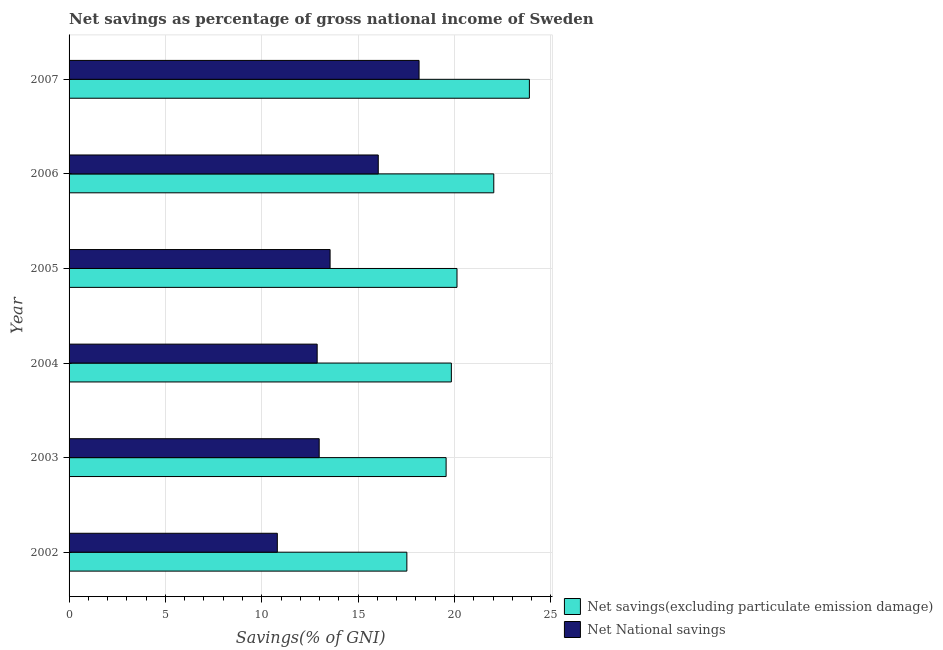How many bars are there on the 6th tick from the top?
Offer a very short reply. 2. What is the label of the 1st group of bars from the top?
Your response must be concise. 2007. What is the net savings(excluding particulate emission damage) in 2007?
Offer a very short reply. 23.89. Across all years, what is the maximum net savings(excluding particulate emission damage)?
Your response must be concise. 23.89. Across all years, what is the minimum net national savings?
Give a very brief answer. 10.81. In which year was the net savings(excluding particulate emission damage) maximum?
Keep it short and to the point. 2007. In which year was the net national savings minimum?
Give a very brief answer. 2002. What is the total net national savings in the graph?
Keep it short and to the point. 84.41. What is the difference between the net national savings in 2003 and that in 2006?
Make the answer very short. -3.07. What is the difference between the net savings(excluding particulate emission damage) in 2003 and the net national savings in 2004?
Your answer should be compact. 6.69. What is the average net national savings per year?
Ensure brevity in your answer.  14.07. In the year 2007, what is the difference between the net savings(excluding particulate emission damage) and net national savings?
Your answer should be compact. 5.73. What is the ratio of the net national savings in 2004 to that in 2006?
Your answer should be compact. 0.8. Is the difference between the net national savings in 2002 and 2006 greater than the difference between the net savings(excluding particulate emission damage) in 2002 and 2006?
Your answer should be very brief. No. What is the difference between the highest and the second highest net national savings?
Your answer should be very brief. 2.12. What is the difference between the highest and the lowest net national savings?
Your response must be concise. 7.35. In how many years, is the net national savings greater than the average net national savings taken over all years?
Make the answer very short. 2. What does the 1st bar from the top in 2002 represents?
Your answer should be very brief. Net National savings. What does the 2nd bar from the bottom in 2002 represents?
Your answer should be very brief. Net National savings. How many bars are there?
Your answer should be very brief. 12. How many years are there in the graph?
Your answer should be very brief. 6. What is the difference between two consecutive major ticks on the X-axis?
Provide a short and direct response. 5. Does the graph contain any zero values?
Make the answer very short. No. Does the graph contain grids?
Provide a succinct answer. Yes. How are the legend labels stacked?
Provide a succinct answer. Vertical. What is the title of the graph?
Your answer should be very brief. Net savings as percentage of gross national income of Sweden. What is the label or title of the X-axis?
Offer a very short reply. Savings(% of GNI). What is the Savings(% of GNI) of Net savings(excluding particulate emission damage) in 2002?
Keep it short and to the point. 17.53. What is the Savings(% of GNI) in Net National savings in 2002?
Make the answer very short. 10.81. What is the Savings(% of GNI) of Net savings(excluding particulate emission damage) in 2003?
Offer a very short reply. 19.57. What is the Savings(% of GNI) in Net National savings in 2003?
Offer a terse response. 12.98. What is the Savings(% of GNI) in Net savings(excluding particulate emission damage) in 2004?
Ensure brevity in your answer.  19.84. What is the Savings(% of GNI) of Net National savings in 2004?
Your answer should be very brief. 12.87. What is the Savings(% of GNI) in Net savings(excluding particulate emission damage) in 2005?
Ensure brevity in your answer.  20.13. What is the Savings(% of GNI) of Net National savings in 2005?
Make the answer very short. 13.54. What is the Savings(% of GNI) in Net savings(excluding particulate emission damage) in 2006?
Offer a very short reply. 22.04. What is the Savings(% of GNI) in Net National savings in 2006?
Offer a very short reply. 16.04. What is the Savings(% of GNI) in Net savings(excluding particulate emission damage) in 2007?
Your response must be concise. 23.89. What is the Savings(% of GNI) of Net National savings in 2007?
Provide a succinct answer. 18.16. Across all years, what is the maximum Savings(% of GNI) in Net savings(excluding particulate emission damage)?
Make the answer very short. 23.89. Across all years, what is the maximum Savings(% of GNI) of Net National savings?
Make the answer very short. 18.16. Across all years, what is the minimum Savings(% of GNI) of Net savings(excluding particulate emission damage)?
Provide a short and direct response. 17.53. Across all years, what is the minimum Savings(% of GNI) of Net National savings?
Your answer should be very brief. 10.81. What is the total Savings(% of GNI) of Net savings(excluding particulate emission damage) in the graph?
Make the answer very short. 122.99. What is the total Savings(% of GNI) of Net National savings in the graph?
Make the answer very short. 84.41. What is the difference between the Savings(% of GNI) of Net savings(excluding particulate emission damage) in 2002 and that in 2003?
Your answer should be very brief. -2.04. What is the difference between the Savings(% of GNI) of Net National savings in 2002 and that in 2003?
Provide a succinct answer. -2.17. What is the difference between the Savings(% of GNI) in Net savings(excluding particulate emission damage) in 2002 and that in 2004?
Offer a very short reply. -2.31. What is the difference between the Savings(% of GNI) in Net National savings in 2002 and that in 2004?
Ensure brevity in your answer.  -2.07. What is the difference between the Savings(% of GNI) of Net savings(excluding particulate emission damage) in 2002 and that in 2005?
Your response must be concise. -2.6. What is the difference between the Savings(% of GNI) of Net National savings in 2002 and that in 2005?
Offer a very short reply. -2.74. What is the difference between the Savings(% of GNI) of Net savings(excluding particulate emission damage) in 2002 and that in 2006?
Offer a terse response. -4.51. What is the difference between the Savings(% of GNI) of Net National savings in 2002 and that in 2006?
Provide a succinct answer. -5.24. What is the difference between the Savings(% of GNI) of Net savings(excluding particulate emission damage) in 2002 and that in 2007?
Offer a very short reply. -6.36. What is the difference between the Savings(% of GNI) in Net National savings in 2002 and that in 2007?
Offer a terse response. -7.35. What is the difference between the Savings(% of GNI) of Net savings(excluding particulate emission damage) in 2003 and that in 2004?
Offer a terse response. -0.27. What is the difference between the Savings(% of GNI) of Net National savings in 2003 and that in 2004?
Provide a succinct answer. 0.1. What is the difference between the Savings(% of GNI) in Net savings(excluding particulate emission damage) in 2003 and that in 2005?
Provide a short and direct response. -0.57. What is the difference between the Savings(% of GNI) in Net National savings in 2003 and that in 2005?
Your answer should be very brief. -0.57. What is the difference between the Savings(% of GNI) of Net savings(excluding particulate emission damage) in 2003 and that in 2006?
Ensure brevity in your answer.  -2.47. What is the difference between the Savings(% of GNI) of Net National savings in 2003 and that in 2006?
Keep it short and to the point. -3.07. What is the difference between the Savings(% of GNI) of Net savings(excluding particulate emission damage) in 2003 and that in 2007?
Make the answer very short. -4.32. What is the difference between the Savings(% of GNI) of Net National savings in 2003 and that in 2007?
Give a very brief answer. -5.18. What is the difference between the Savings(% of GNI) in Net savings(excluding particulate emission damage) in 2004 and that in 2005?
Offer a very short reply. -0.29. What is the difference between the Savings(% of GNI) of Net National savings in 2004 and that in 2005?
Keep it short and to the point. -0.67. What is the difference between the Savings(% of GNI) of Net savings(excluding particulate emission damage) in 2004 and that in 2006?
Make the answer very short. -2.2. What is the difference between the Savings(% of GNI) in Net National savings in 2004 and that in 2006?
Provide a short and direct response. -3.17. What is the difference between the Savings(% of GNI) of Net savings(excluding particulate emission damage) in 2004 and that in 2007?
Your response must be concise. -4.05. What is the difference between the Savings(% of GNI) in Net National savings in 2004 and that in 2007?
Your response must be concise. -5.29. What is the difference between the Savings(% of GNI) of Net savings(excluding particulate emission damage) in 2005 and that in 2006?
Your response must be concise. -1.91. What is the difference between the Savings(% of GNI) of Net National savings in 2005 and that in 2006?
Give a very brief answer. -2.5. What is the difference between the Savings(% of GNI) of Net savings(excluding particulate emission damage) in 2005 and that in 2007?
Keep it short and to the point. -3.76. What is the difference between the Savings(% of GNI) of Net National savings in 2005 and that in 2007?
Provide a short and direct response. -4.62. What is the difference between the Savings(% of GNI) of Net savings(excluding particulate emission damage) in 2006 and that in 2007?
Give a very brief answer. -1.85. What is the difference between the Savings(% of GNI) in Net National savings in 2006 and that in 2007?
Keep it short and to the point. -2.12. What is the difference between the Savings(% of GNI) in Net savings(excluding particulate emission damage) in 2002 and the Savings(% of GNI) in Net National savings in 2003?
Offer a terse response. 4.55. What is the difference between the Savings(% of GNI) in Net savings(excluding particulate emission damage) in 2002 and the Savings(% of GNI) in Net National savings in 2004?
Ensure brevity in your answer.  4.65. What is the difference between the Savings(% of GNI) in Net savings(excluding particulate emission damage) in 2002 and the Savings(% of GNI) in Net National savings in 2005?
Provide a succinct answer. 3.98. What is the difference between the Savings(% of GNI) in Net savings(excluding particulate emission damage) in 2002 and the Savings(% of GNI) in Net National savings in 2006?
Give a very brief answer. 1.48. What is the difference between the Savings(% of GNI) of Net savings(excluding particulate emission damage) in 2002 and the Savings(% of GNI) of Net National savings in 2007?
Offer a very short reply. -0.63. What is the difference between the Savings(% of GNI) of Net savings(excluding particulate emission damage) in 2003 and the Savings(% of GNI) of Net National savings in 2004?
Keep it short and to the point. 6.69. What is the difference between the Savings(% of GNI) of Net savings(excluding particulate emission damage) in 2003 and the Savings(% of GNI) of Net National savings in 2005?
Offer a very short reply. 6.02. What is the difference between the Savings(% of GNI) of Net savings(excluding particulate emission damage) in 2003 and the Savings(% of GNI) of Net National savings in 2006?
Your response must be concise. 3.52. What is the difference between the Savings(% of GNI) of Net savings(excluding particulate emission damage) in 2003 and the Savings(% of GNI) of Net National savings in 2007?
Offer a terse response. 1.4. What is the difference between the Savings(% of GNI) in Net savings(excluding particulate emission damage) in 2004 and the Savings(% of GNI) in Net National savings in 2005?
Provide a short and direct response. 6.29. What is the difference between the Savings(% of GNI) of Net savings(excluding particulate emission damage) in 2004 and the Savings(% of GNI) of Net National savings in 2006?
Give a very brief answer. 3.79. What is the difference between the Savings(% of GNI) in Net savings(excluding particulate emission damage) in 2004 and the Savings(% of GNI) in Net National savings in 2007?
Your response must be concise. 1.68. What is the difference between the Savings(% of GNI) in Net savings(excluding particulate emission damage) in 2005 and the Savings(% of GNI) in Net National savings in 2006?
Give a very brief answer. 4.09. What is the difference between the Savings(% of GNI) of Net savings(excluding particulate emission damage) in 2005 and the Savings(% of GNI) of Net National savings in 2007?
Your answer should be compact. 1.97. What is the difference between the Savings(% of GNI) of Net savings(excluding particulate emission damage) in 2006 and the Savings(% of GNI) of Net National savings in 2007?
Your answer should be compact. 3.88. What is the average Savings(% of GNI) of Net savings(excluding particulate emission damage) per year?
Your answer should be very brief. 20.5. What is the average Savings(% of GNI) in Net National savings per year?
Make the answer very short. 14.07. In the year 2002, what is the difference between the Savings(% of GNI) of Net savings(excluding particulate emission damage) and Savings(% of GNI) of Net National savings?
Give a very brief answer. 6.72. In the year 2003, what is the difference between the Savings(% of GNI) of Net savings(excluding particulate emission damage) and Savings(% of GNI) of Net National savings?
Provide a short and direct response. 6.59. In the year 2004, what is the difference between the Savings(% of GNI) of Net savings(excluding particulate emission damage) and Savings(% of GNI) of Net National savings?
Provide a succinct answer. 6.96. In the year 2005, what is the difference between the Savings(% of GNI) in Net savings(excluding particulate emission damage) and Savings(% of GNI) in Net National savings?
Keep it short and to the point. 6.59. In the year 2006, what is the difference between the Savings(% of GNI) in Net savings(excluding particulate emission damage) and Savings(% of GNI) in Net National savings?
Provide a short and direct response. 5.99. In the year 2007, what is the difference between the Savings(% of GNI) of Net savings(excluding particulate emission damage) and Savings(% of GNI) of Net National savings?
Make the answer very short. 5.73. What is the ratio of the Savings(% of GNI) in Net savings(excluding particulate emission damage) in 2002 to that in 2003?
Offer a very short reply. 0.9. What is the ratio of the Savings(% of GNI) of Net National savings in 2002 to that in 2003?
Provide a succinct answer. 0.83. What is the ratio of the Savings(% of GNI) of Net savings(excluding particulate emission damage) in 2002 to that in 2004?
Keep it short and to the point. 0.88. What is the ratio of the Savings(% of GNI) of Net National savings in 2002 to that in 2004?
Provide a short and direct response. 0.84. What is the ratio of the Savings(% of GNI) in Net savings(excluding particulate emission damage) in 2002 to that in 2005?
Your answer should be compact. 0.87. What is the ratio of the Savings(% of GNI) of Net National savings in 2002 to that in 2005?
Your response must be concise. 0.8. What is the ratio of the Savings(% of GNI) in Net savings(excluding particulate emission damage) in 2002 to that in 2006?
Provide a short and direct response. 0.8. What is the ratio of the Savings(% of GNI) in Net National savings in 2002 to that in 2006?
Your answer should be very brief. 0.67. What is the ratio of the Savings(% of GNI) in Net savings(excluding particulate emission damage) in 2002 to that in 2007?
Your answer should be compact. 0.73. What is the ratio of the Savings(% of GNI) of Net National savings in 2002 to that in 2007?
Ensure brevity in your answer.  0.6. What is the ratio of the Savings(% of GNI) in Net savings(excluding particulate emission damage) in 2003 to that in 2004?
Provide a succinct answer. 0.99. What is the ratio of the Savings(% of GNI) in Net savings(excluding particulate emission damage) in 2003 to that in 2005?
Your response must be concise. 0.97. What is the ratio of the Savings(% of GNI) of Net National savings in 2003 to that in 2005?
Offer a terse response. 0.96. What is the ratio of the Savings(% of GNI) of Net savings(excluding particulate emission damage) in 2003 to that in 2006?
Your response must be concise. 0.89. What is the ratio of the Savings(% of GNI) in Net National savings in 2003 to that in 2006?
Make the answer very short. 0.81. What is the ratio of the Savings(% of GNI) in Net savings(excluding particulate emission damage) in 2003 to that in 2007?
Keep it short and to the point. 0.82. What is the ratio of the Savings(% of GNI) of Net National savings in 2003 to that in 2007?
Your response must be concise. 0.71. What is the ratio of the Savings(% of GNI) in Net savings(excluding particulate emission damage) in 2004 to that in 2005?
Provide a succinct answer. 0.99. What is the ratio of the Savings(% of GNI) of Net National savings in 2004 to that in 2005?
Your response must be concise. 0.95. What is the ratio of the Savings(% of GNI) of Net savings(excluding particulate emission damage) in 2004 to that in 2006?
Your answer should be very brief. 0.9. What is the ratio of the Savings(% of GNI) in Net National savings in 2004 to that in 2006?
Give a very brief answer. 0.8. What is the ratio of the Savings(% of GNI) in Net savings(excluding particulate emission damage) in 2004 to that in 2007?
Give a very brief answer. 0.83. What is the ratio of the Savings(% of GNI) of Net National savings in 2004 to that in 2007?
Offer a very short reply. 0.71. What is the ratio of the Savings(% of GNI) in Net savings(excluding particulate emission damage) in 2005 to that in 2006?
Provide a succinct answer. 0.91. What is the ratio of the Savings(% of GNI) of Net National savings in 2005 to that in 2006?
Your answer should be compact. 0.84. What is the ratio of the Savings(% of GNI) of Net savings(excluding particulate emission damage) in 2005 to that in 2007?
Offer a very short reply. 0.84. What is the ratio of the Savings(% of GNI) in Net National savings in 2005 to that in 2007?
Make the answer very short. 0.75. What is the ratio of the Savings(% of GNI) in Net savings(excluding particulate emission damage) in 2006 to that in 2007?
Provide a short and direct response. 0.92. What is the ratio of the Savings(% of GNI) in Net National savings in 2006 to that in 2007?
Your answer should be compact. 0.88. What is the difference between the highest and the second highest Savings(% of GNI) of Net savings(excluding particulate emission damage)?
Offer a terse response. 1.85. What is the difference between the highest and the second highest Savings(% of GNI) of Net National savings?
Make the answer very short. 2.12. What is the difference between the highest and the lowest Savings(% of GNI) in Net savings(excluding particulate emission damage)?
Your answer should be compact. 6.36. What is the difference between the highest and the lowest Savings(% of GNI) in Net National savings?
Give a very brief answer. 7.35. 